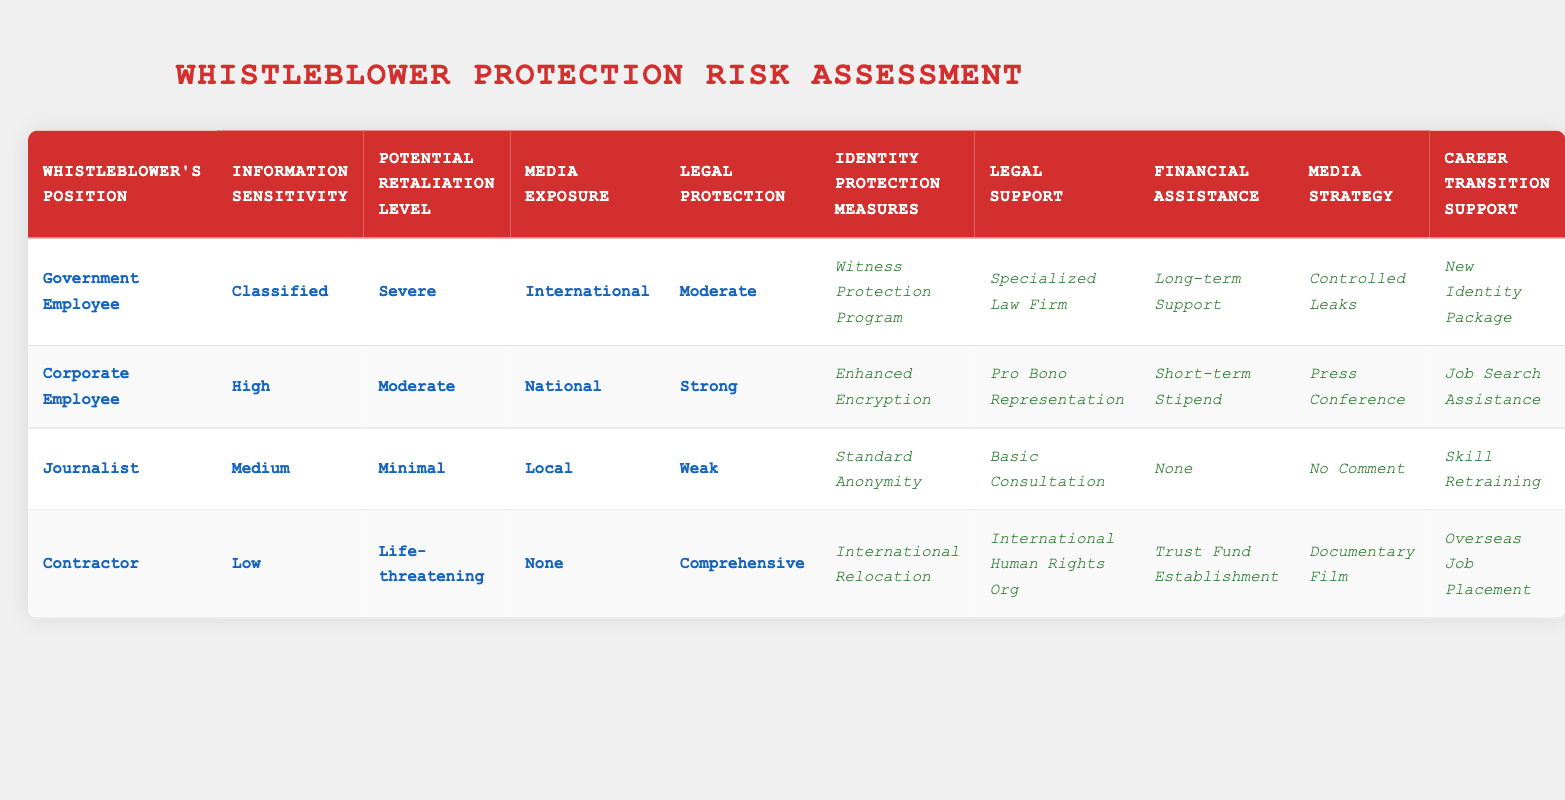What support is offered to a Government Employee dealing with Classified information and Severe retaliation? According to the table, a Government Employee facing Classified information and Severe retaliation is provided with the Witness Protection Program, Specialized Law Firm, Long-term Support, Controlled Leaks, and New Identity Package.
Answer: Witness Protection Program, Specialized Law Firm, Long-term Support, Controlled Leaks, New Identity Package Is there a Career Transition Support option for a Journalist under Weak legal protection? Yes, the data indicates that a Journalist under Weak legal protection is provided with Skill Retraining as the Career Transition Support option.
Answer: Yes What is the Financial Assistance available for a Corporate Employee facing High sensitivity information and Moderate retaliation? The table shows that a Corporate Employee with High sensitivity and Moderate retaliation is entitled to Short-term Stipend as Financial Assistance.
Answer: Short-term Stipend Can a Contractor expect International Relocation as a protection measure for Low sensitivity information and Life-threatening retaliation? Yes, according to the table, a Contractor facing Low sensitivity and Life-threatening retaliation can expect International Relocation as an Identity Protection Measure.
Answer: Yes What is the most comprehensive level of Legal Support available and which whistleblower profile receives it? The most comprehensive level of Legal Support is from an International Human Rights Organization. This is provided to a Contractor who faces Low sensitivity information and Life-threatening retaliation.
Answer: International Human Rights Org for Contractor What combination of factors leads to Enhanced Encryption for a whistleblower? Enhanced Encryption is provided for a Corporate Employee dealing with High sensitivity information and Moderate retaliation in a National media exposure context that has Strong legal protection.
Answer: Corporate Employee How many Identity Protection Measures are available for a Government Employee under Moderate legal protection? A Government Employee under Moderate legal protection facing Classified information and Severe retaliation has five Identity Protection Measures available, which are Witness Protection Program, Enhanced Encryption, Long-term Support, Controlled Leaks, and New Identity Package.
Answer: Five measures Is 'No Comment' a recommended Media Strategy for someone in a local journalism context with Minimal retaliation? Yes, 'No Comment' is specifically indicated as the Media Strategy recommended for a Journalist facing Medium sensitivity with Minimal retaliation and Local media exposure.
Answer: Yes 